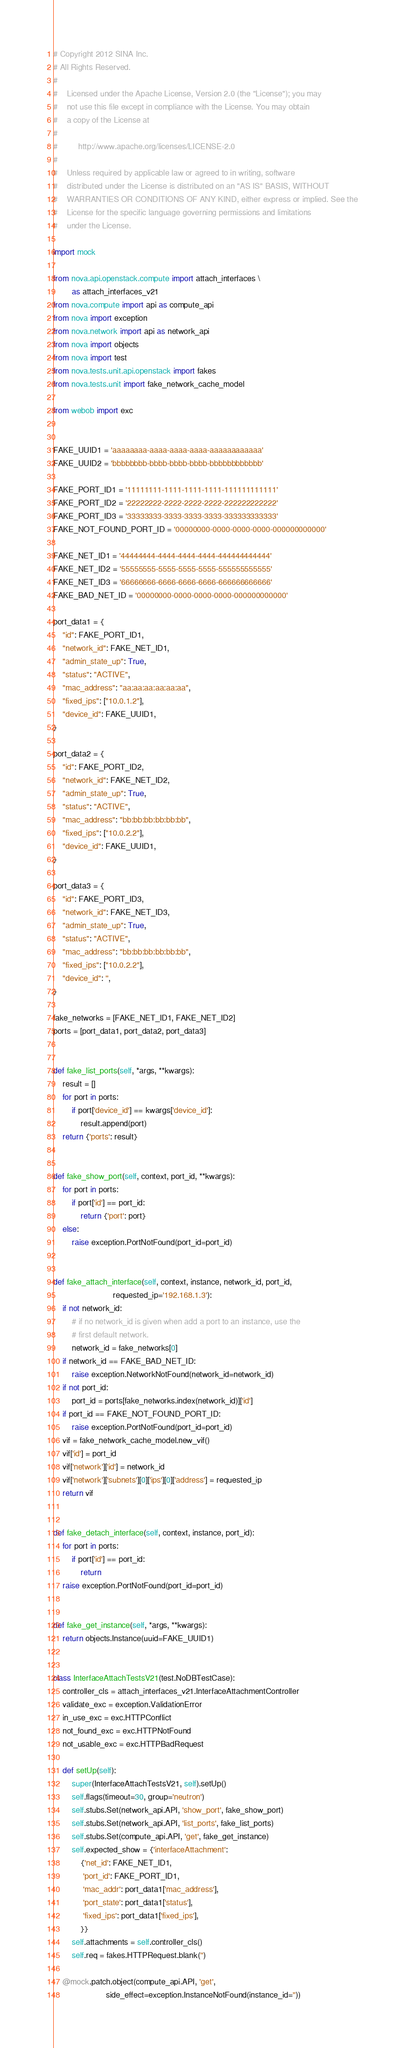Convert code to text. <code><loc_0><loc_0><loc_500><loc_500><_Python_># Copyright 2012 SINA Inc.
# All Rights Reserved.
#
#    Licensed under the Apache License, Version 2.0 (the "License"); you may
#    not use this file except in compliance with the License. You may obtain
#    a copy of the License at
#
#         http://www.apache.org/licenses/LICENSE-2.0
#
#    Unless required by applicable law or agreed to in writing, software
#    distributed under the License is distributed on an "AS IS" BASIS, WITHOUT
#    WARRANTIES OR CONDITIONS OF ANY KIND, either express or implied. See the
#    License for the specific language governing permissions and limitations
#    under the License.

import mock

from nova.api.openstack.compute import attach_interfaces \
        as attach_interfaces_v21
from nova.compute import api as compute_api
from nova import exception
from nova.network import api as network_api
from nova import objects
from nova import test
from nova.tests.unit.api.openstack import fakes
from nova.tests.unit import fake_network_cache_model

from webob import exc


FAKE_UUID1 = 'aaaaaaaa-aaaa-aaaa-aaaa-aaaaaaaaaaaa'
FAKE_UUID2 = 'bbbbbbbb-bbbb-bbbb-bbbb-bbbbbbbbbbbb'

FAKE_PORT_ID1 = '11111111-1111-1111-1111-111111111111'
FAKE_PORT_ID2 = '22222222-2222-2222-2222-222222222222'
FAKE_PORT_ID3 = '33333333-3333-3333-3333-333333333333'
FAKE_NOT_FOUND_PORT_ID = '00000000-0000-0000-0000-000000000000'

FAKE_NET_ID1 = '44444444-4444-4444-4444-444444444444'
FAKE_NET_ID2 = '55555555-5555-5555-5555-555555555555'
FAKE_NET_ID3 = '66666666-6666-6666-6666-666666666666'
FAKE_BAD_NET_ID = '00000000-0000-0000-0000-000000000000'

port_data1 = {
    "id": FAKE_PORT_ID1,
    "network_id": FAKE_NET_ID1,
    "admin_state_up": True,
    "status": "ACTIVE",
    "mac_address": "aa:aa:aa:aa:aa:aa",
    "fixed_ips": ["10.0.1.2"],
    "device_id": FAKE_UUID1,
}

port_data2 = {
    "id": FAKE_PORT_ID2,
    "network_id": FAKE_NET_ID2,
    "admin_state_up": True,
    "status": "ACTIVE",
    "mac_address": "bb:bb:bb:bb:bb:bb",
    "fixed_ips": ["10.0.2.2"],
    "device_id": FAKE_UUID1,
}

port_data3 = {
    "id": FAKE_PORT_ID3,
    "network_id": FAKE_NET_ID3,
    "admin_state_up": True,
    "status": "ACTIVE",
    "mac_address": "bb:bb:bb:bb:bb:bb",
    "fixed_ips": ["10.0.2.2"],
    "device_id": '',
}

fake_networks = [FAKE_NET_ID1, FAKE_NET_ID2]
ports = [port_data1, port_data2, port_data3]


def fake_list_ports(self, *args, **kwargs):
    result = []
    for port in ports:
        if port['device_id'] == kwargs['device_id']:
            result.append(port)
    return {'ports': result}


def fake_show_port(self, context, port_id, **kwargs):
    for port in ports:
        if port['id'] == port_id:
            return {'port': port}
    else:
        raise exception.PortNotFound(port_id=port_id)


def fake_attach_interface(self, context, instance, network_id, port_id,
                          requested_ip='192.168.1.3'):
    if not network_id:
        # if no network_id is given when add a port to an instance, use the
        # first default network.
        network_id = fake_networks[0]
    if network_id == FAKE_BAD_NET_ID:
        raise exception.NetworkNotFound(network_id=network_id)
    if not port_id:
        port_id = ports[fake_networks.index(network_id)]['id']
    if port_id == FAKE_NOT_FOUND_PORT_ID:
        raise exception.PortNotFound(port_id=port_id)
    vif = fake_network_cache_model.new_vif()
    vif['id'] = port_id
    vif['network']['id'] = network_id
    vif['network']['subnets'][0]['ips'][0]['address'] = requested_ip
    return vif


def fake_detach_interface(self, context, instance, port_id):
    for port in ports:
        if port['id'] == port_id:
            return
    raise exception.PortNotFound(port_id=port_id)


def fake_get_instance(self, *args, **kwargs):
    return objects.Instance(uuid=FAKE_UUID1)


class InterfaceAttachTestsV21(test.NoDBTestCase):
    controller_cls = attach_interfaces_v21.InterfaceAttachmentController
    validate_exc = exception.ValidationError
    in_use_exc = exc.HTTPConflict
    not_found_exc = exc.HTTPNotFound
    not_usable_exc = exc.HTTPBadRequest

    def setUp(self):
        super(InterfaceAttachTestsV21, self).setUp()
        self.flags(timeout=30, group='neutron')
        self.stubs.Set(network_api.API, 'show_port', fake_show_port)
        self.stubs.Set(network_api.API, 'list_ports', fake_list_ports)
        self.stubs.Set(compute_api.API, 'get', fake_get_instance)
        self.expected_show = {'interfaceAttachment':
            {'net_id': FAKE_NET_ID1,
             'port_id': FAKE_PORT_ID1,
             'mac_addr': port_data1['mac_address'],
             'port_state': port_data1['status'],
             'fixed_ips': port_data1['fixed_ips'],
            }}
        self.attachments = self.controller_cls()
        self.req = fakes.HTTPRequest.blank('')

    @mock.patch.object(compute_api.API, 'get',
                       side_effect=exception.InstanceNotFound(instance_id=''))</code> 